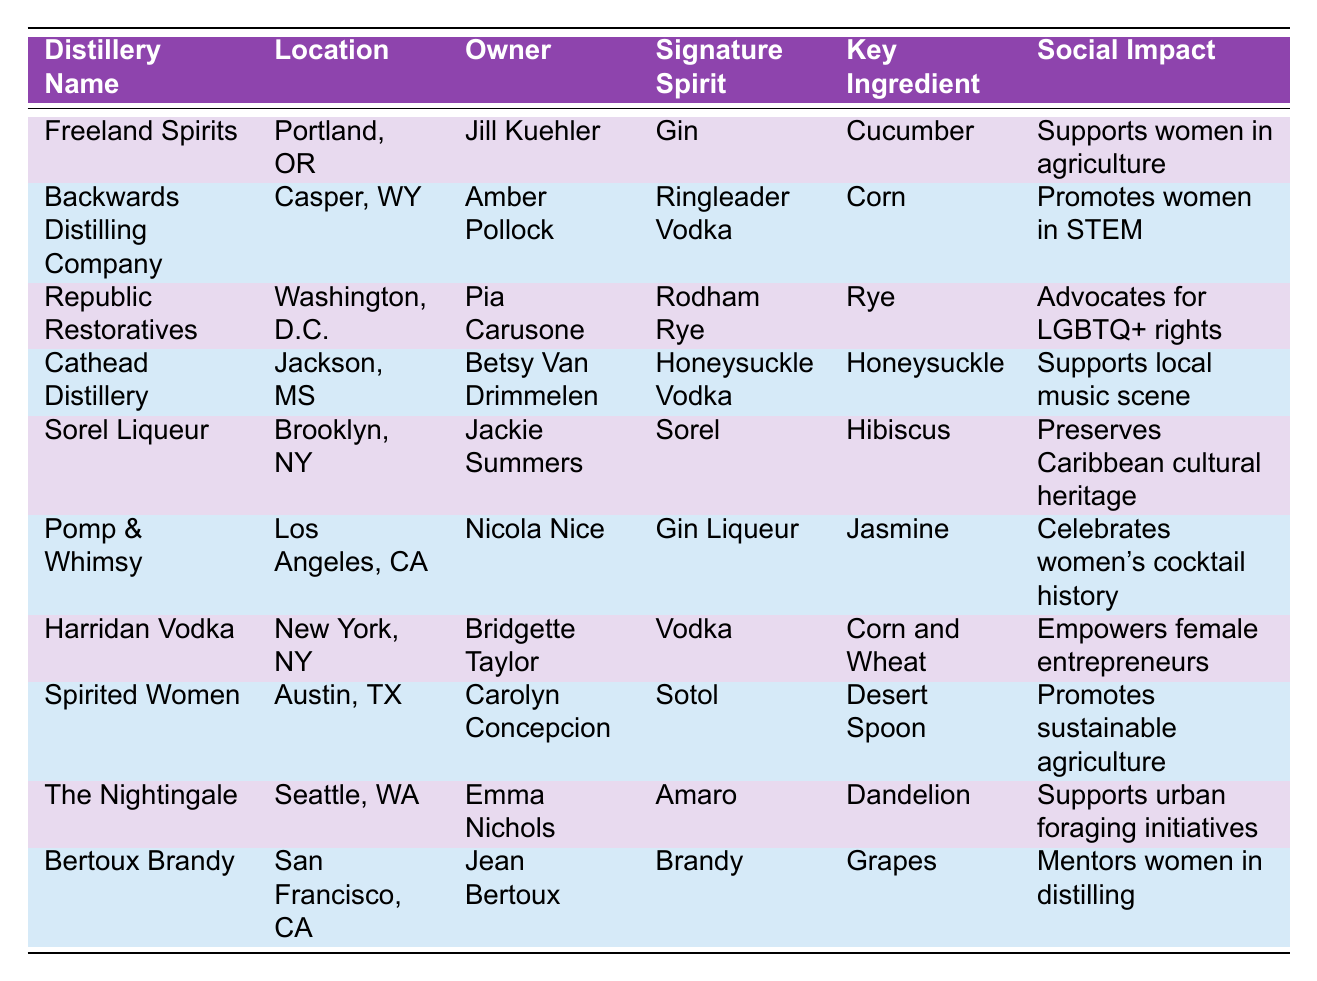What is the signature spirit of Freeland Spirits? The table shows that Freeland Spirits has "Gin" as its signature spirit.
Answer: Gin Which distillery is owned by Bridgette Taylor? According to the table, Bridgette Taylor owns Harridan Vodka.
Answer: Harridan Vodka What key ingredient is used in the signature spirit of Backwards Distilling Company? The table indicates that the key ingredient for Ringleader Vodka, produced by Backwards Distilling Company, is "Corn."
Answer: Corn Which distillery supports women in agriculture? The table states that Freeland Spirits supports women in agriculture.
Answer: Freeland Spirits Are there any distilleries that promote women in STEM? The table lists Backwards Distilling Company as one that promotes women in STEM.
Answer: Yes What is the social impact listed for Republic Restoratives? The table notes that Republic Restoratives advocates for LGBTQ+ rights as its social impact.
Answer: Advocates for LGBTQ+ rights How many distilleries are located in California? The table shows two distilleries located in California: Pomp & Whimsy and Bertoux Brandy.
Answer: 2 Which signature spirit incorporates hibiscus as a key ingredient? From the table, Sorel Liqueur has hibiscus as its key ingredient.
Answer: Sorel Which distillery is associated with supporting the local music scene? The table indicates that Cathead Distillery supports the local music scene.
Answer: Cathead Distillery Compare the social impacts of Harridan Vodka and The Nightingale. Harridan Vodka empowers female entrepreneurs, while The Nightingale supports urban foraging initiatives. Both have different focuses on social impact.
Answer: Different focuses: Harridan Vodka empowers female entrepreneurs; The Nightingale supports urban foraging initiatives 